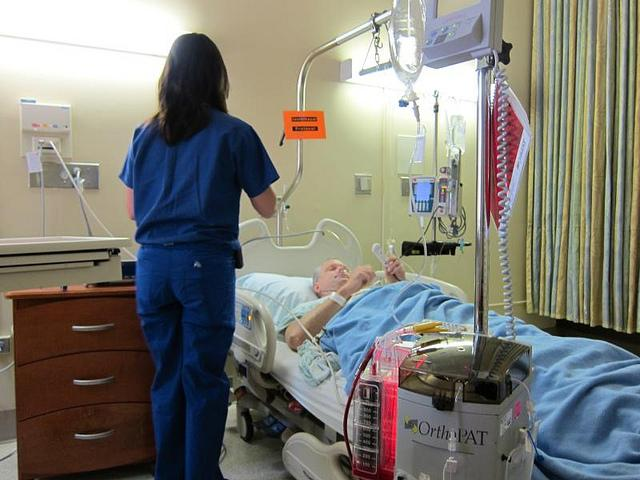Where is the man laying?

Choices:
A) couch
B) beach
C) floor
D) hospital bed hospital bed 